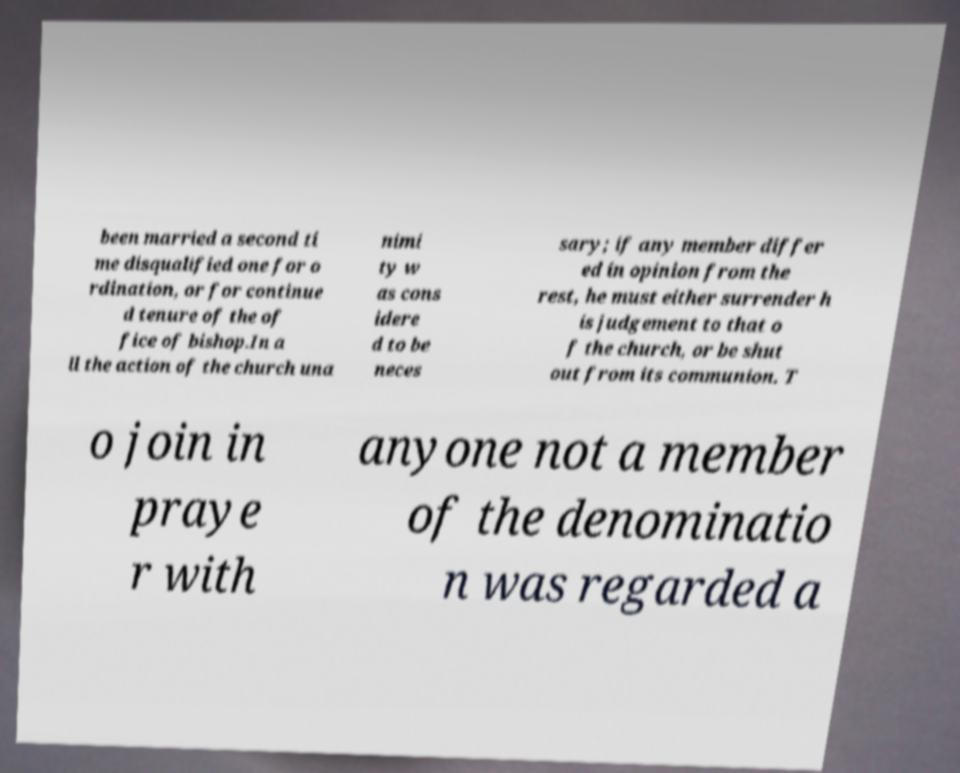Please identify and transcribe the text found in this image. been married a second ti me disqualified one for o rdination, or for continue d tenure of the of fice of bishop.In a ll the action of the church una nimi ty w as cons idere d to be neces sary; if any member differ ed in opinion from the rest, he must either surrender h is judgement to that o f the church, or be shut out from its communion. T o join in praye r with anyone not a member of the denominatio n was regarded a 